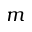<formula> <loc_0><loc_0><loc_500><loc_500>m</formula> 